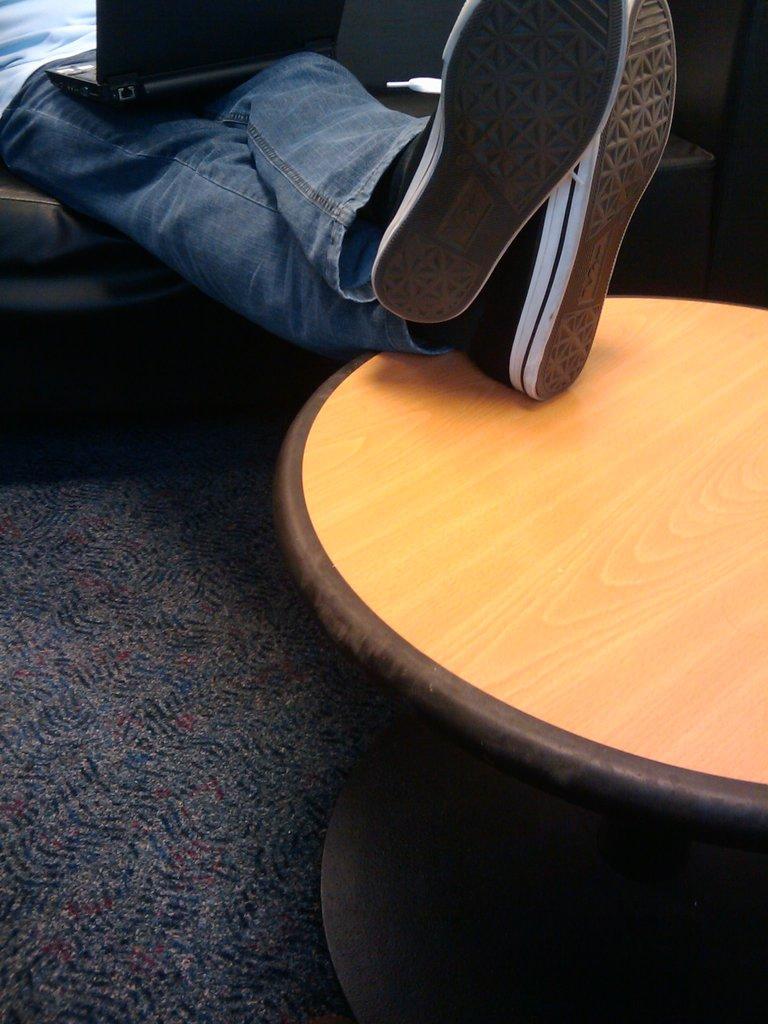In one or two sentences, can you explain what this image depicts? In this image I see a laptop on person's leg and the legs are on a table. 